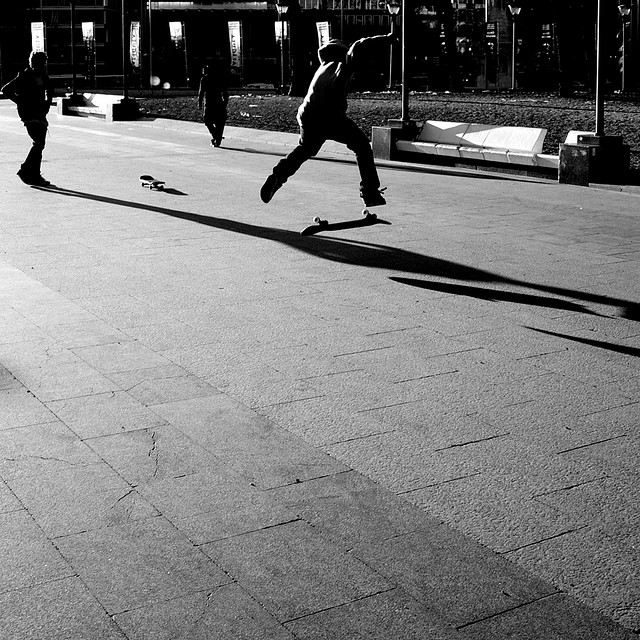<image>What color is the rug? There is no rug in the image. What color is the rug? There is no rug in the image. 